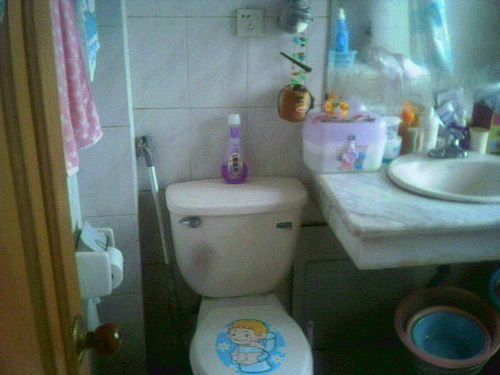Describe the objects in this image and their specific colors. I can see toilet in teal, gray, darkgray, and black tones, sink in teal, darkgray, gray, and lightblue tones, cup in teal, darkgray, and lightblue tones, cup in teal, gray, and darkgray tones, and cup in teal, gray, and darkgray tones in this image. 